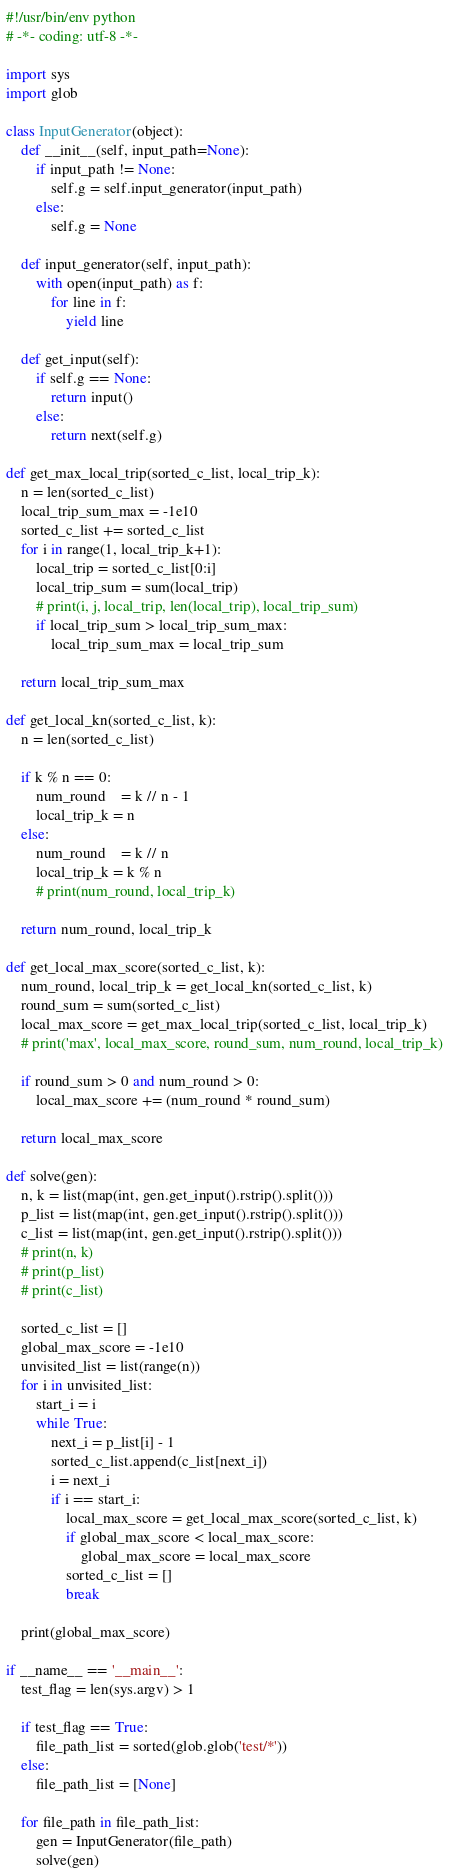<code> <loc_0><loc_0><loc_500><loc_500><_Python_>#!/usr/bin/env python
# -*- coding: utf-8 -*-

import sys
import glob

class InputGenerator(object):
    def __init__(self, input_path=None):
        if input_path != None:
            self.g = self.input_generator(input_path)
        else:
            self.g = None

    def input_generator(self, input_path):
        with open(input_path) as f:
            for line in f:
                yield line

    def get_input(self):
        if self.g == None:
            return input()
        else:
            return next(self.g)

def get_max_local_trip(sorted_c_list, local_trip_k):
    n = len(sorted_c_list)
    local_trip_sum_max = -1e10
    sorted_c_list += sorted_c_list
    for i in range(1, local_trip_k+1):
        local_trip = sorted_c_list[0:i]
        local_trip_sum = sum(local_trip)
        # print(i, j, local_trip, len(local_trip), local_trip_sum)
        if local_trip_sum > local_trip_sum_max:
            local_trip_sum_max = local_trip_sum

    return local_trip_sum_max

def get_local_kn(sorted_c_list, k):
    n = len(sorted_c_list)

    if k % n == 0:
        num_round    = k // n - 1
        local_trip_k = n
    else:
        num_round    = k // n
        local_trip_k = k % n
        # print(num_round, local_trip_k)

    return num_round, local_trip_k

def get_local_max_score(sorted_c_list, k):
    num_round, local_trip_k = get_local_kn(sorted_c_list, k)
    round_sum = sum(sorted_c_list)
    local_max_score = get_max_local_trip(sorted_c_list, local_trip_k)
    # print('max', local_max_score, round_sum, num_round, local_trip_k)

    if round_sum > 0 and num_round > 0:
        local_max_score += (num_round * round_sum)

    return local_max_score

def solve(gen):
    n, k = list(map(int, gen.get_input().rstrip().split()))
    p_list = list(map(int, gen.get_input().rstrip().split()))
    c_list = list(map(int, gen.get_input().rstrip().split()))
    # print(n, k)
    # print(p_list)
    # print(c_list)

    sorted_c_list = []
    global_max_score = -1e10
    unvisited_list = list(range(n))
    for i in unvisited_list:
        start_i = i
        while True:
            next_i = p_list[i] - 1
            sorted_c_list.append(c_list[next_i])
            i = next_i
            if i == start_i:
                local_max_score = get_local_max_score(sorted_c_list, k)
                if global_max_score < local_max_score:
                    global_max_score = local_max_score
                sorted_c_list = []
                break

    print(global_max_score)

if __name__ == '__main__':
    test_flag = len(sys.argv) > 1

    if test_flag == True:
        file_path_list = sorted(glob.glob('test/*'))
    else:
        file_path_list = [None]

    for file_path in file_path_list:
        gen = InputGenerator(file_path)
        solve(gen)
</code> 